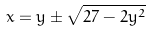Convert formula to latex. <formula><loc_0><loc_0><loc_500><loc_500>x = y \pm \sqrt { 2 7 - 2 y ^ { 2 } }</formula> 